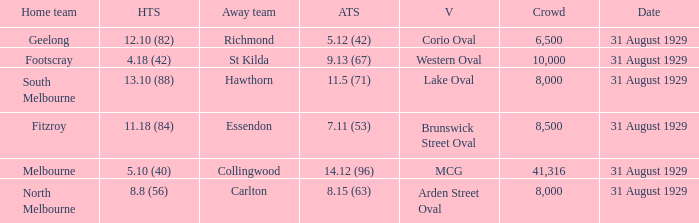What date was the game when the away team was carlton? 31 August 1929. 